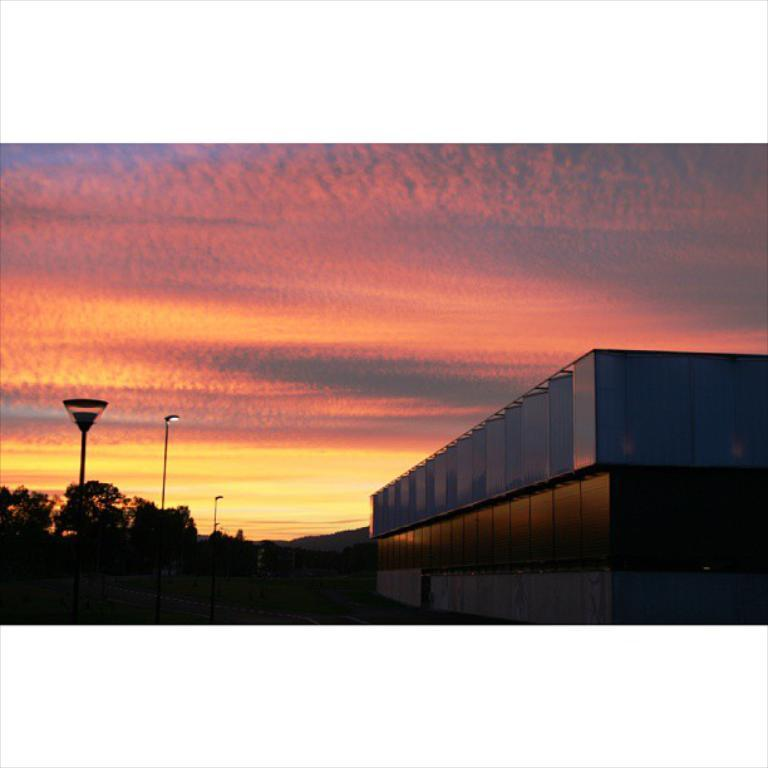What type of structure is visible in the image? There is a building in the image. What type of vegetation is present in the image? There is grass and trees in the image. What are the light poles used for in the image? The light poles are in the grass, likely for illumination purposes. What is visible at the top of the image? The sky is visible at the top of the image. Can you tell me how many ministers are present in the image? There is no minister present in the image; it features a building, grass, trees, and light poles. What type of lead can be seen in the image? There is no lead present in the image. 